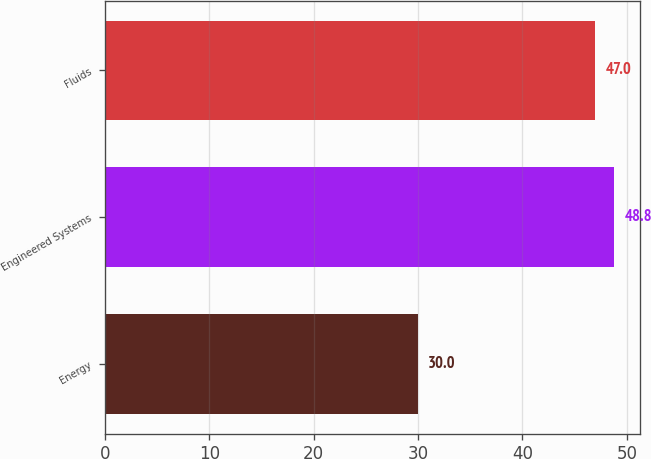Convert chart. <chart><loc_0><loc_0><loc_500><loc_500><bar_chart><fcel>Energy<fcel>Engineered Systems<fcel>Fluids<nl><fcel>30<fcel>48.8<fcel>47<nl></chart> 